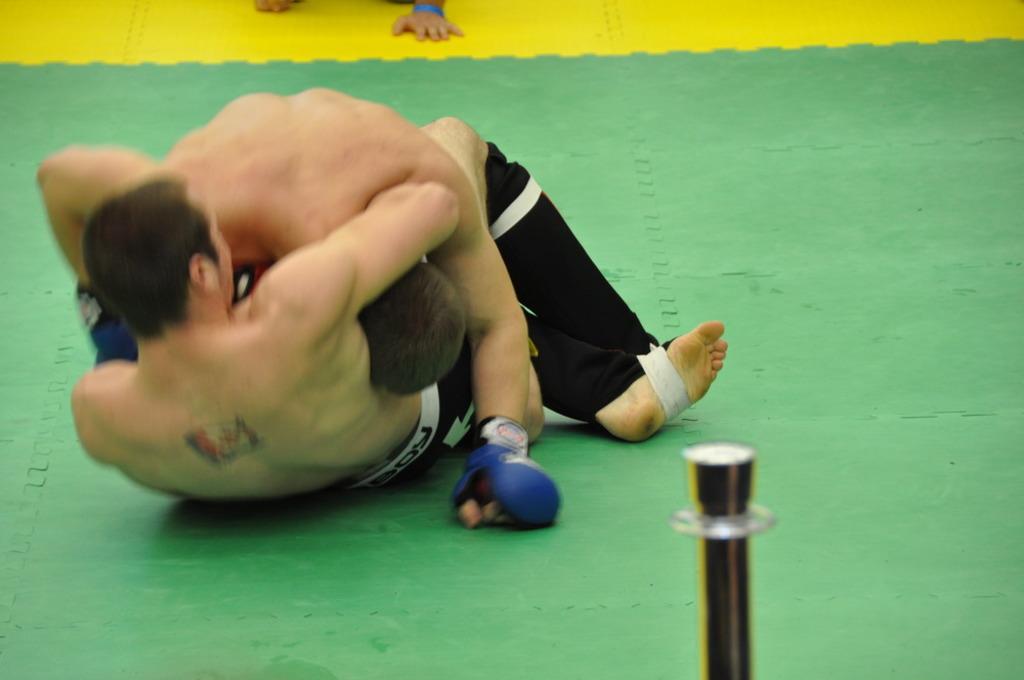Could you give a brief overview of what you see in this image? In this image there are two men who are boxing with each other by rolling on the floor without the shirts. At the bottom there is a pole. In the background there are hands which are kept on the mat. 